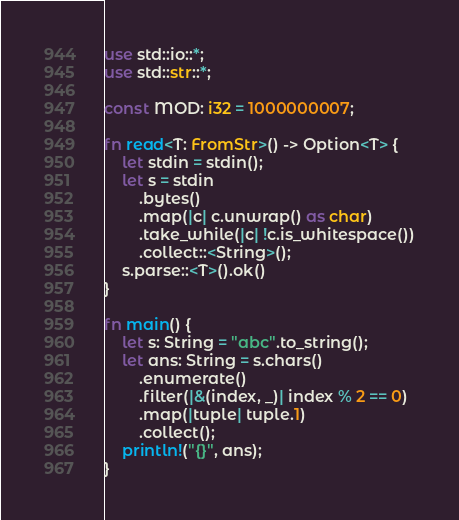Convert code to text. <code><loc_0><loc_0><loc_500><loc_500><_Rust_>use std::io::*;
use std::str::*;

const MOD: i32 = 1000000007;

fn read<T: FromStr>() -> Option<T> {
    let stdin = stdin();
    let s = stdin
        .bytes()
        .map(|c| c.unwrap() as char)
        .take_while(|c| !c.is_whitespace())
        .collect::<String>();
    s.parse::<T>().ok()
}

fn main() {
    let s: String = "abc".to_string();
    let ans: String = s.chars()
        .enumerate()
        .filter(|&(index, _)| index % 2 == 0)
        .map(|tuple| tuple.1)
        .collect();
    println!("{}", ans);
}
</code> 